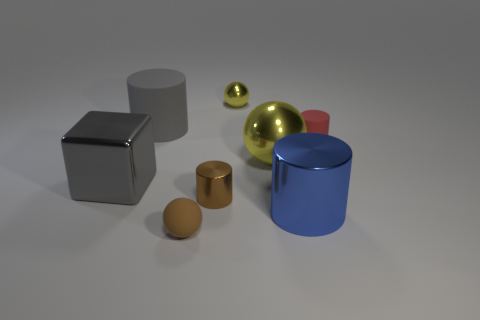Is the number of spheres that are behind the brown shiny thing less than the number of cylinders behind the small brown matte ball?
Offer a terse response. Yes. The cube has what color?
Your answer should be compact. Gray. Is there a metal thing that has the same color as the big sphere?
Your answer should be compact. Yes. There is a tiny brown object that is right of the tiny ball left of the small brown object behind the blue metal cylinder; what shape is it?
Keep it short and to the point. Cylinder. What is the yellow ball that is in front of the red rubber cylinder made of?
Offer a very short reply. Metal. What size is the yellow object that is behind the tiny cylinder that is behind the large shiny thing to the left of the big yellow metal sphere?
Your response must be concise. Small. There is a brown rubber sphere; is its size the same as the shiny sphere on the right side of the small yellow metal ball?
Give a very brief answer. No. There is a large metal object that is to the left of the large ball; what is its color?
Provide a succinct answer. Gray. There is a matte thing that is the same color as the small metallic cylinder; what is its shape?
Make the answer very short. Sphere. There is a matte thing that is in front of the gray metal block; what shape is it?
Offer a terse response. Sphere. 